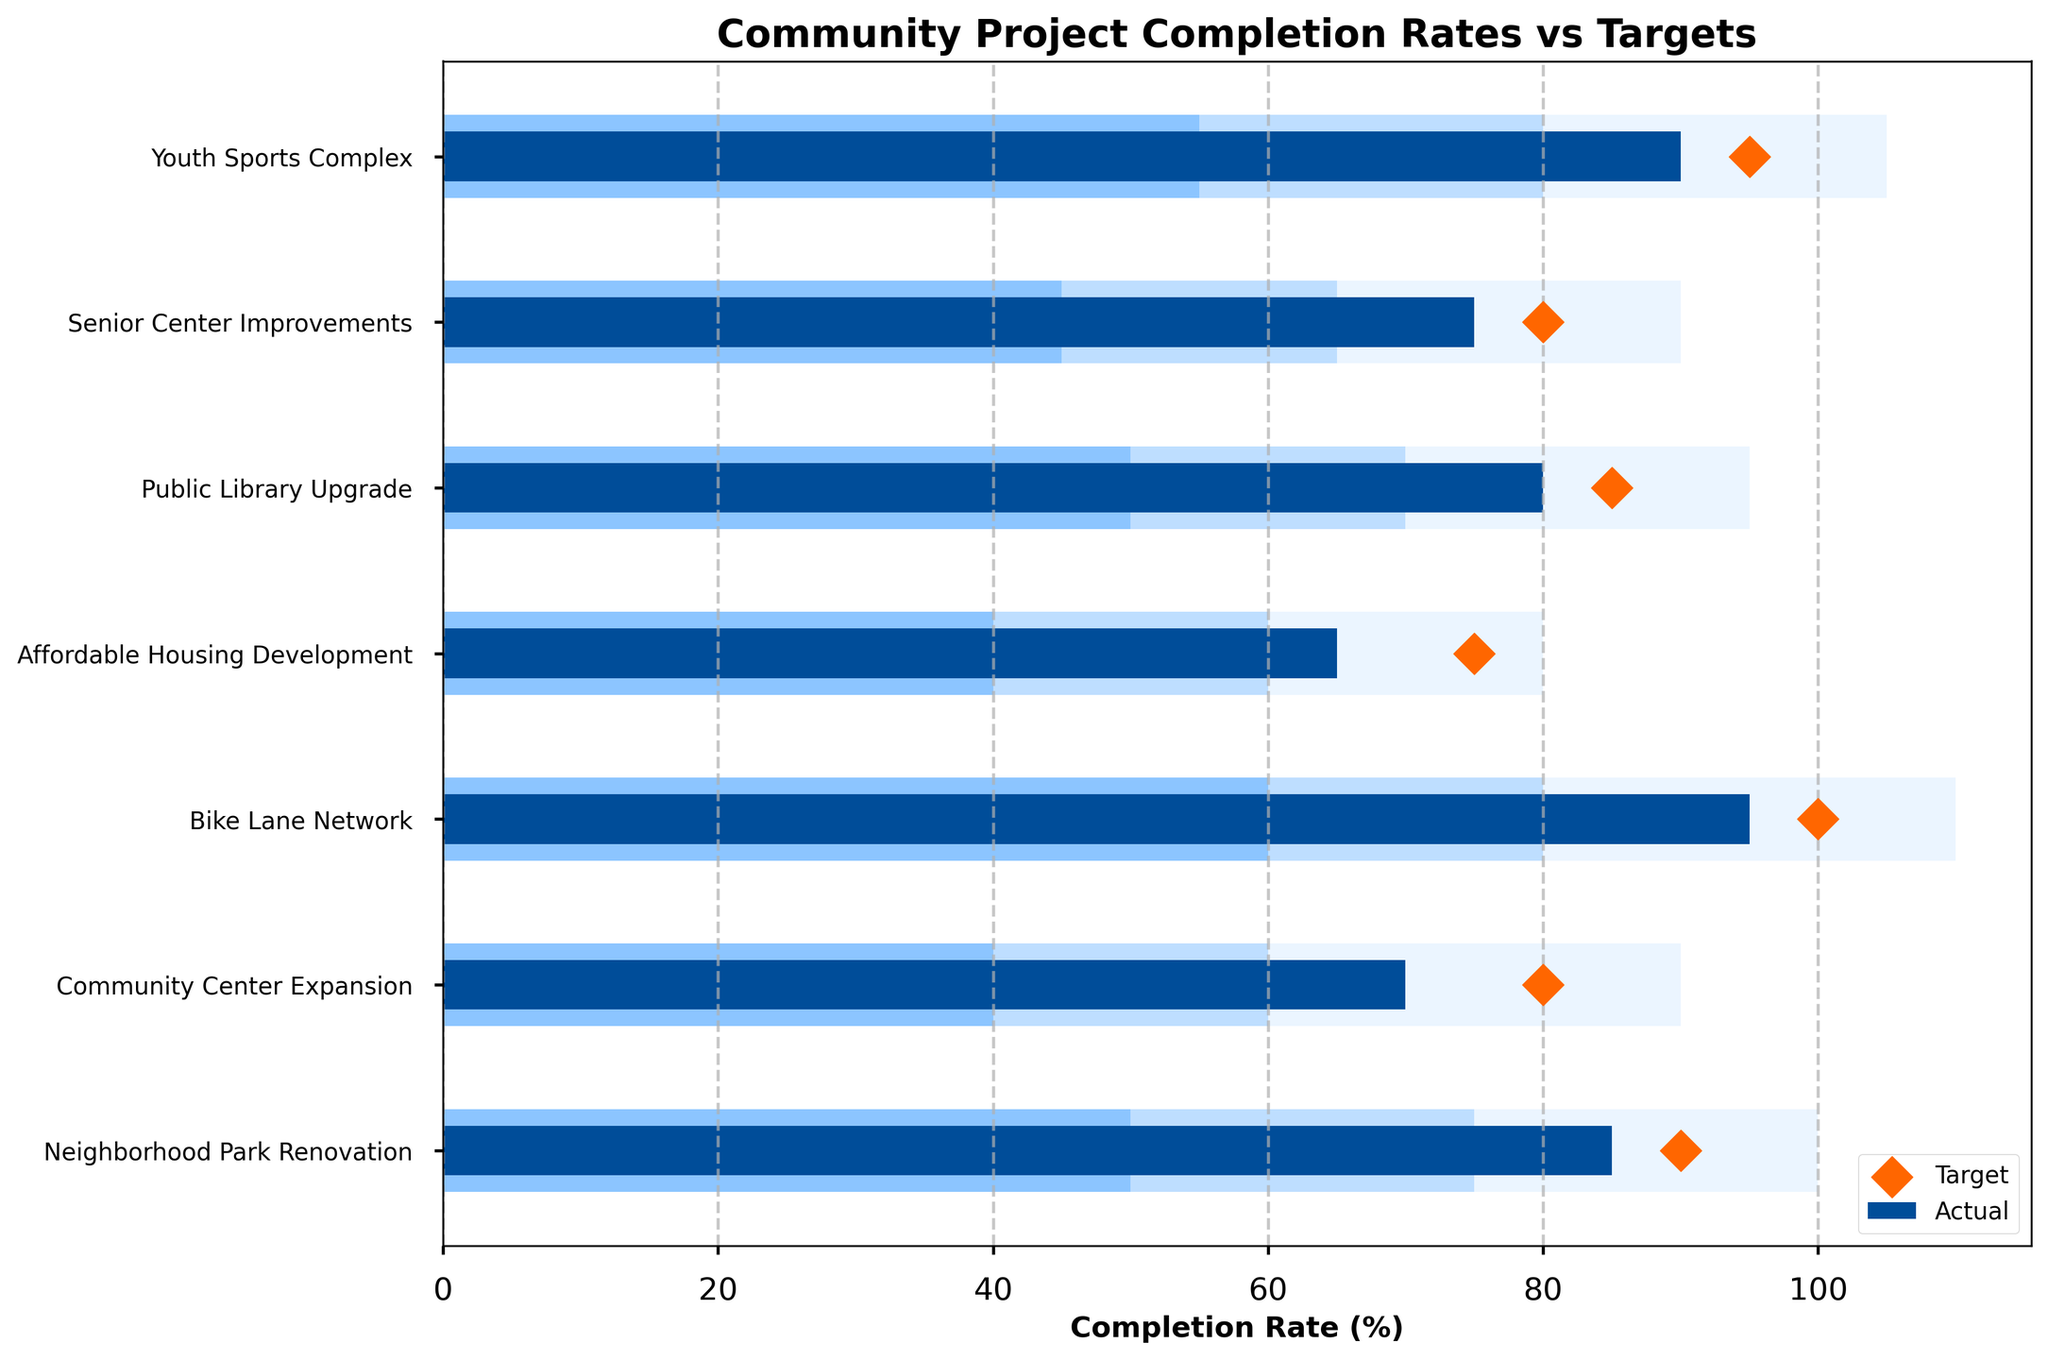What is the title of the chart? The title of the chart is typically located at the top of the figure in bold text, stating the general subject of the visualization. In this case, the title is "Community Project Completion Rates vs Targets".
Answer: Community Project Completion Rates vs Targets Which project has the highest actual completion rate? The actual completion rates are shown in dark blue bars. By scanning these bars, the one with the highest value corresponds to the "Bike Lane Network" project.
Answer: Bike Lane Network What is the target completion rate for the Senior Center Improvements project? The target completion rates are denoted by orange diamond markers. Locate the marker for the "Senior Center Improvements" row to determine its target completion rate, which is 80%.
Answer: 80% Which project has an actual completion rate below its target? Compare the actual completion rates (dark blue bars) with the target markers (orange diamonds). Any project where the diamond is to the right of the blue bar has an actual rate below its target. Projects fitting this description include: "Community Center Expansion," "Affordable Housing Development," "Public Library Upgrade," and "Senior Center Improvements".
Answer: Community Center Expansion, Affordable Housing Development, Public Library Upgrade, Senior Center Improvements How many projects have an actual completion rate above 80%? Examine the length of the dark blue bars. Count the number of projects with bars extending past the 80% mark on the x-axis: "Neighborhood Park Renovation," "Bike Lane Network," "Public Library Upgrade," and "Youth Sports Complex."
Answer: 4 What is the difference between the actual and target completion rates of the Community Center Expansion project? Subtract the actual completion rate (70%) from the target completion rate (80%) for the "Community Center Expansion" project. The difference is 80% - 70% = 10%.
Answer: 10% Which project has the smallest gap between its actual and target completion rates? Calculate the differences for each project: 
Neighborhood Park Renovation: 90% - 85% = 5%
Community Center Expansion: 80% - 70% = 10%
Bike Lane Network: 100% - 95% = 5%
Affordable Housing Development: 75% - 65% = 10%
Public Library Upgrade: 85% - 80% = 5%
Senior Center Improvements: 80% - 75% = 5%
Youth Sports Complex: 95% - 90% = 5%. All projects with 5% gaps (Neighborhood Park Renovation, Bike Lane Network, Public Library Upgrade, Senior Center Improvements, and Youth Sports Complex) share the smallest gap.
Answer: Neighborhood Park Renovation, Bike Lane Network, Public Library Upgrade, Senior Center Improvements, Youth Sports Complex Which project falls into the "Good" completion range based on its actual completion rate? The "Good" completion range is indicated by the lightest blue background bars. Examine where the dark blue bars fall in relation to this background color. Projects with actual completion rates within the "Good" range are: "Neighborhood Park Renovation," "Bike Lane Network," "Youth Sports Complex."
Answer: Neighborhood Park Renovation, Bike Lane Network, Youth Sports Complex 